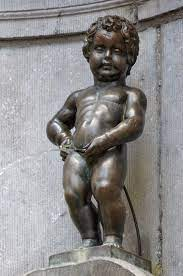Explain the visual content of the image in great detail. The image features the famous Manneken Pis statue, a notable historical landmark of Brussels, Belgium. Cast in bronze, this small sculpture portrays a boy urinating into a basin of a fountain. Positioned on a stone pedestal, the boy is depicted mid-action, with water visibly cascading from him. The statue is framed against a weathered stone wall, with subtle traces of moss, suggesting its age and exposure to elements. This delightful figure is not just artwork; it serves as a whimsical embodiment of the city's folklore and has numerous costumes for various occasions, symbolizing the city’s light-hearted spirit in face of its complex history. 